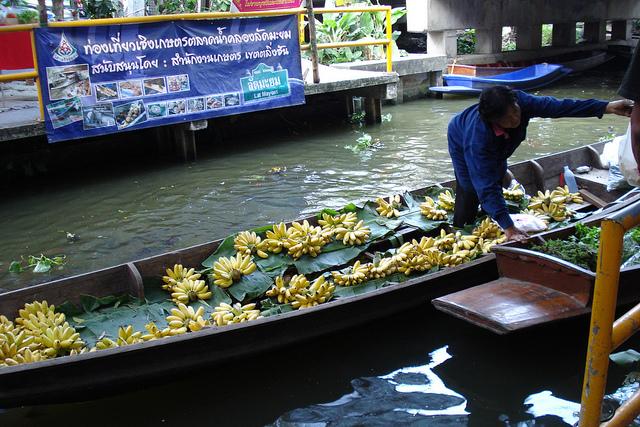What fruits are these?
Keep it brief. Bananas. How long until the bananas are ripe?
Short answer required. Now. What are workers doing to the bananas?
Give a very brief answer. Transporting. Is the boat in the water?
Quick response, please. Yes. Where is the woman?
Answer briefly. Boat. 